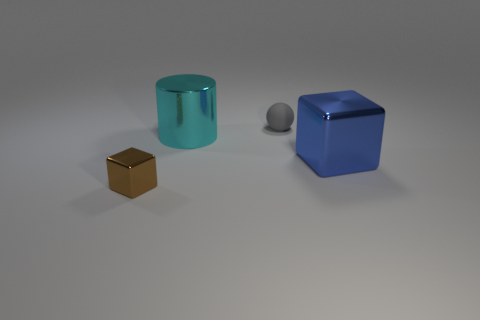Is there any other thing that is made of the same material as the ball?
Provide a short and direct response. No. What shape is the big thing that is the same material as the big cylinder?
Keep it short and to the point. Cube. Is the number of blue cubes that are to the right of the shiny cylinder greater than the number of big purple things?
Offer a terse response. Yes. What material is the cylinder?
Your answer should be very brief. Metal. What number of brown objects are the same size as the cyan metal thing?
Your answer should be very brief. 0. Are there the same number of blue metal things in front of the large blue metallic thing and small brown metal blocks that are in front of the brown metal object?
Give a very brief answer. Yes. Are the cyan cylinder and the small block made of the same material?
Make the answer very short. Yes. There is a big object that is to the left of the large blue metal block; are there any cubes to the left of it?
Give a very brief answer. Yes. Is there a large brown object of the same shape as the big blue shiny object?
Offer a terse response. No. There is a small thing right of the shiny thing in front of the big metal block; what is its material?
Give a very brief answer. Rubber. 